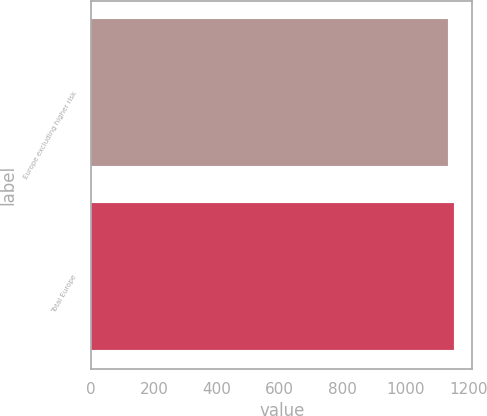Convert chart to OTSL. <chart><loc_0><loc_0><loc_500><loc_500><bar_chart><fcel>Europe excluding higher risk<fcel>Total Europe<nl><fcel>1135<fcel>1154<nl></chart> 